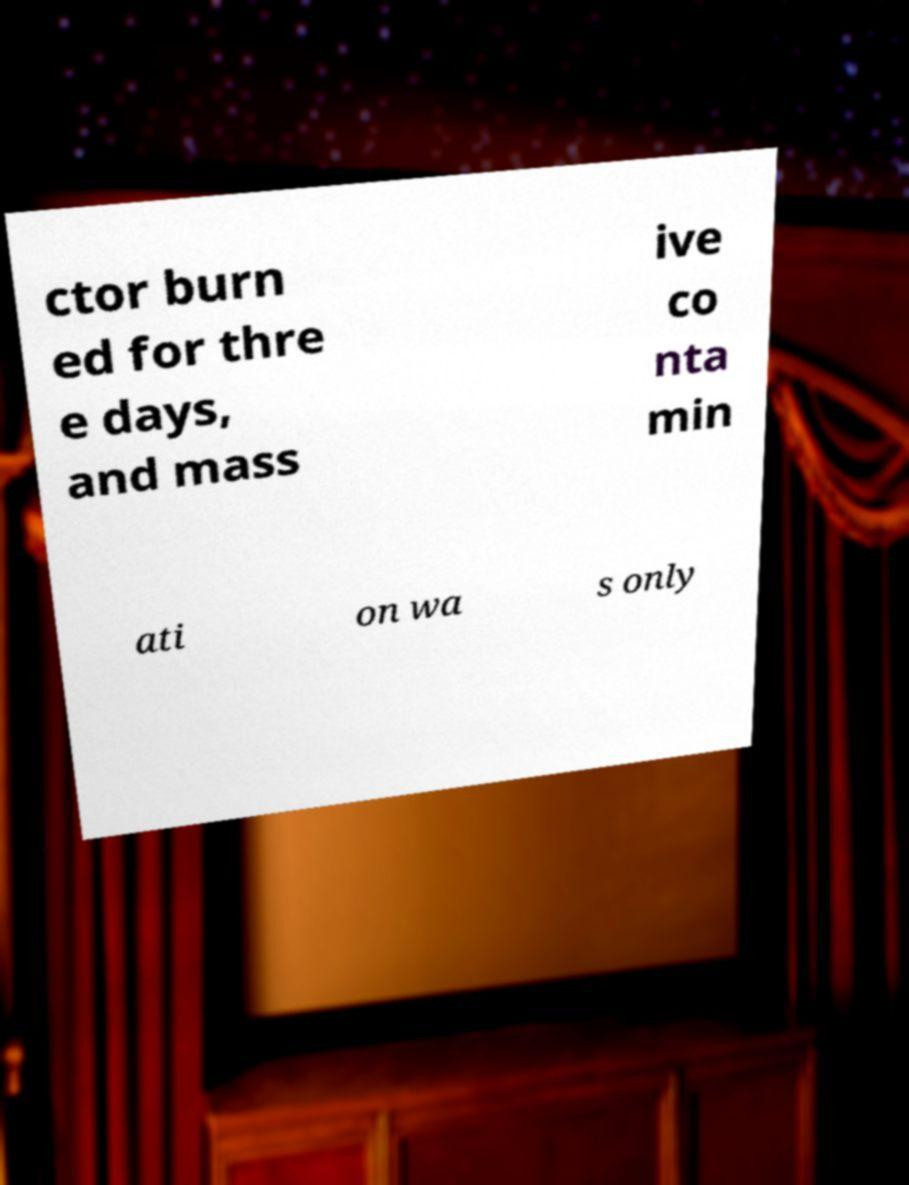For documentation purposes, I need the text within this image transcribed. Could you provide that? ctor burn ed for thre e days, and mass ive co nta min ati on wa s only 